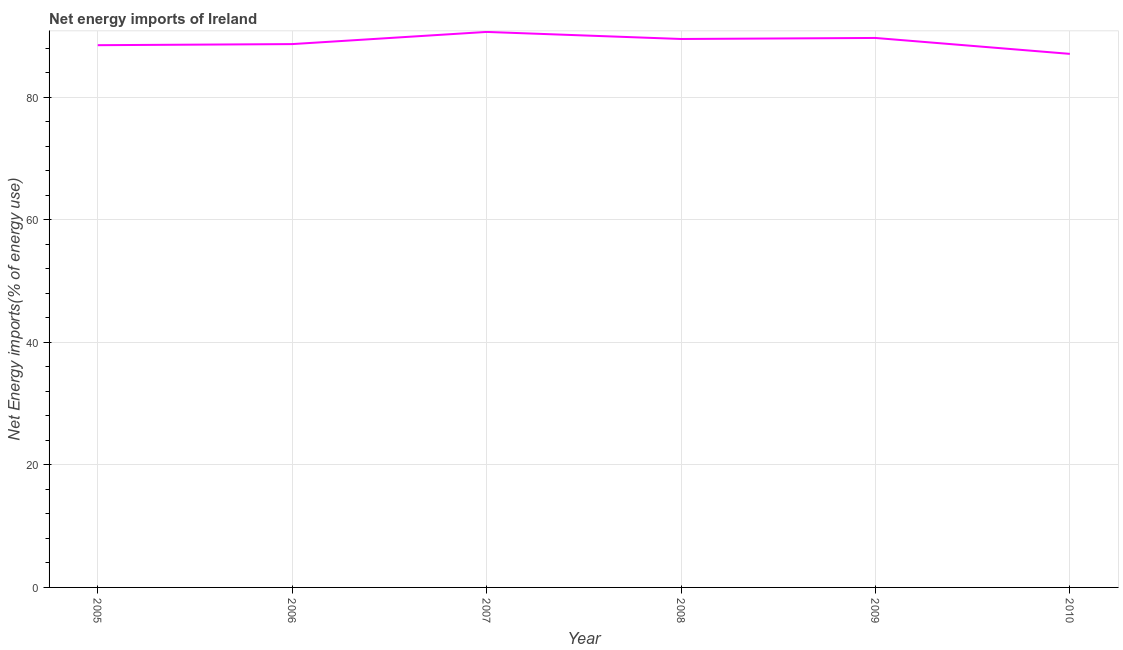What is the energy imports in 2009?
Ensure brevity in your answer.  89.7. Across all years, what is the maximum energy imports?
Provide a succinct answer. 90.69. Across all years, what is the minimum energy imports?
Ensure brevity in your answer.  87.11. In which year was the energy imports minimum?
Give a very brief answer. 2010. What is the sum of the energy imports?
Make the answer very short. 534.26. What is the difference between the energy imports in 2005 and 2008?
Offer a terse response. -1.01. What is the average energy imports per year?
Offer a terse response. 89.04. What is the median energy imports?
Offer a terse response. 89.12. In how many years, is the energy imports greater than 8 %?
Ensure brevity in your answer.  6. Do a majority of the years between 2005 and 2007 (inclusive) have energy imports greater than 20 %?
Give a very brief answer. Yes. What is the ratio of the energy imports in 2008 to that in 2009?
Your answer should be very brief. 1. Is the energy imports in 2005 less than that in 2007?
Give a very brief answer. Yes. Is the difference between the energy imports in 2006 and 2009 greater than the difference between any two years?
Your answer should be very brief. No. What is the difference between the highest and the second highest energy imports?
Make the answer very short. 0.99. What is the difference between the highest and the lowest energy imports?
Offer a very short reply. 3.58. What is the difference between two consecutive major ticks on the Y-axis?
Keep it short and to the point. 20. Does the graph contain any zero values?
Offer a very short reply. No. What is the title of the graph?
Your answer should be very brief. Net energy imports of Ireland. What is the label or title of the X-axis?
Offer a terse response. Year. What is the label or title of the Y-axis?
Offer a terse response. Net Energy imports(% of energy use). What is the Net Energy imports(% of energy use) in 2005?
Give a very brief answer. 88.52. What is the Net Energy imports(% of energy use) in 2006?
Your answer should be very brief. 88.7. What is the Net Energy imports(% of energy use) in 2007?
Provide a short and direct response. 90.69. What is the Net Energy imports(% of energy use) of 2008?
Offer a very short reply. 89.54. What is the Net Energy imports(% of energy use) of 2009?
Your response must be concise. 89.7. What is the Net Energy imports(% of energy use) of 2010?
Provide a succinct answer. 87.11. What is the difference between the Net Energy imports(% of energy use) in 2005 and 2006?
Offer a very short reply. -0.18. What is the difference between the Net Energy imports(% of energy use) in 2005 and 2007?
Provide a short and direct response. -2.17. What is the difference between the Net Energy imports(% of energy use) in 2005 and 2008?
Your answer should be compact. -1.01. What is the difference between the Net Energy imports(% of energy use) in 2005 and 2009?
Give a very brief answer. -1.18. What is the difference between the Net Energy imports(% of energy use) in 2005 and 2010?
Make the answer very short. 1.42. What is the difference between the Net Energy imports(% of energy use) in 2006 and 2007?
Your response must be concise. -1.99. What is the difference between the Net Energy imports(% of energy use) in 2006 and 2008?
Your response must be concise. -0.83. What is the difference between the Net Energy imports(% of energy use) in 2006 and 2009?
Your answer should be very brief. -1. What is the difference between the Net Energy imports(% of energy use) in 2006 and 2010?
Your answer should be very brief. 1.6. What is the difference between the Net Energy imports(% of energy use) in 2007 and 2008?
Your answer should be compact. 1.15. What is the difference between the Net Energy imports(% of energy use) in 2007 and 2009?
Give a very brief answer. 0.99. What is the difference between the Net Energy imports(% of energy use) in 2007 and 2010?
Your response must be concise. 3.58. What is the difference between the Net Energy imports(% of energy use) in 2008 and 2009?
Provide a short and direct response. -0.17. What is the difference between the Net Energy imports(% of energy use) in 2008 and 2010?
Your answer should be very brief. 2.43. What is the difference between the Net Energy imports(% of energy use) in 2009 and 2010?
Provide a short and direct response. 2.6. What is the ratio of the Net Energy imports(% of energy use) in 2005 to that in 2006?
Your answer should be compact. 1. What is the ratio of the Net Energy imports(% of energy use) in 2005 to that in 2007?
Offer a very short reply. 0.98. What is the ratio of the Net Energy imports(% of energy use) in 2005 to that in 2009?
Make the answer very short. 0.99. What is the ratio of the Net Energy imports(% of energy use) in 2005 to that in 2010?
Your answer should be compact. 1.02. What is the ratio of the Net Energy imports(% of energy use) in 2006 to that in 2010?
Provide a short and direct response. 1.02. What is the ratio of the Net Energy imports(% of energy use) in 2007 to that in 2008?
Offer a very short reply. 1.01. What is the ratio of the Net Energy imports(% of energy use) in 2007 to that in 2010?
Offer a terse response. 1.04. What is the ratio of the Net Energy imports(% of energy use) in 2008 to that in 2009?
Give a very brief answer. 1. What is the ratio of the Net Energy imports(% of energy use) in 2008 to that in 2010?
Your answer should be compact. 1.03. 